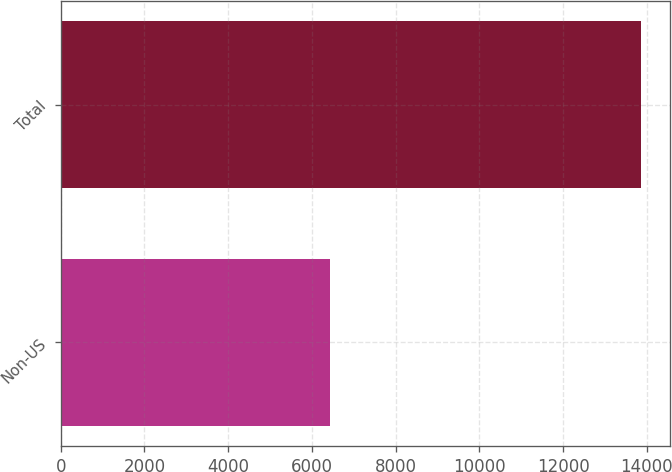Convert chart. <chart><loc_0><loc_0><loc_500><loc_500><bar_chart><fcel>Non-US<fcel>Total<nl><fcel>6444<fcel>13861<nl></chart> 